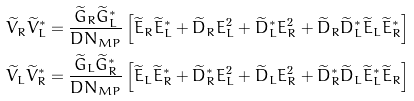Convert formula to latex. <formula><loc_0><loc_0><loc_500><loc_500>\widetilde { V } _ { R } \widetilde { V } _ { L } ^ { * } & = \frac { \widetilde { G } _ { R } \widetilde { G } _ { L } ^ { * } } { D N _ { M P } } \left [ \widetilde { E } _ { R } \widetilde { E } _ { L } ^ { * } + \widetilde { D } _ { R } E _ { L } ^ { 2 } + \widetilde { D } _ { L } ^ { * } E _ { R } ^ { 2 } + \widetilde { D } _ { R } \widetilde { D } _ { L } ^ { * } \widetilde { E } _ { L } \widetilde { E } _ { R } ^ { * } \right ] \\ \widetilde { V } _ { L } \widetilde { V } _ { R } ^ { * } & = \frac { \widetilde { G } _ { L } \widetilde { G } _ { R } ^ { * } } { D N _ { M P } } \left [ \widetilde { E } _ { L } \widetilde { E } _ { R } ^ { * } + \widetilde { D } _ { R } ^ { * } E _ { L } ^ { 2 } + \widetilde { D } _ { L } E _ { R } ^ { 2 } + \widetilde { D } _ { R } ^ { * } \widetilde { D } _ { L } \widetilde { E } _ { L } ^ { * } \widetilde { E } _ { R } \right ]</formula> 